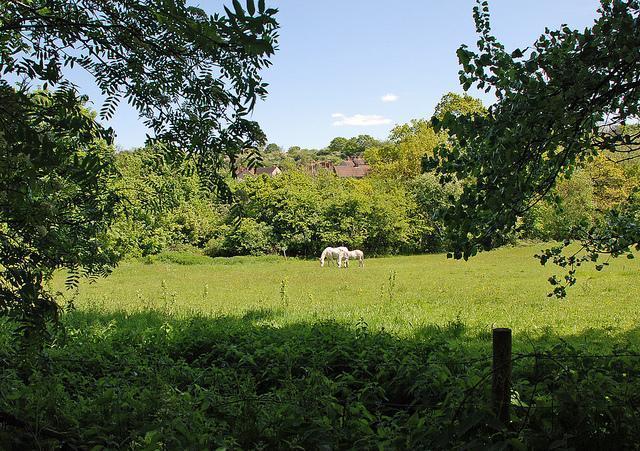How many benches are here?
Give a very brief answer. 0. 